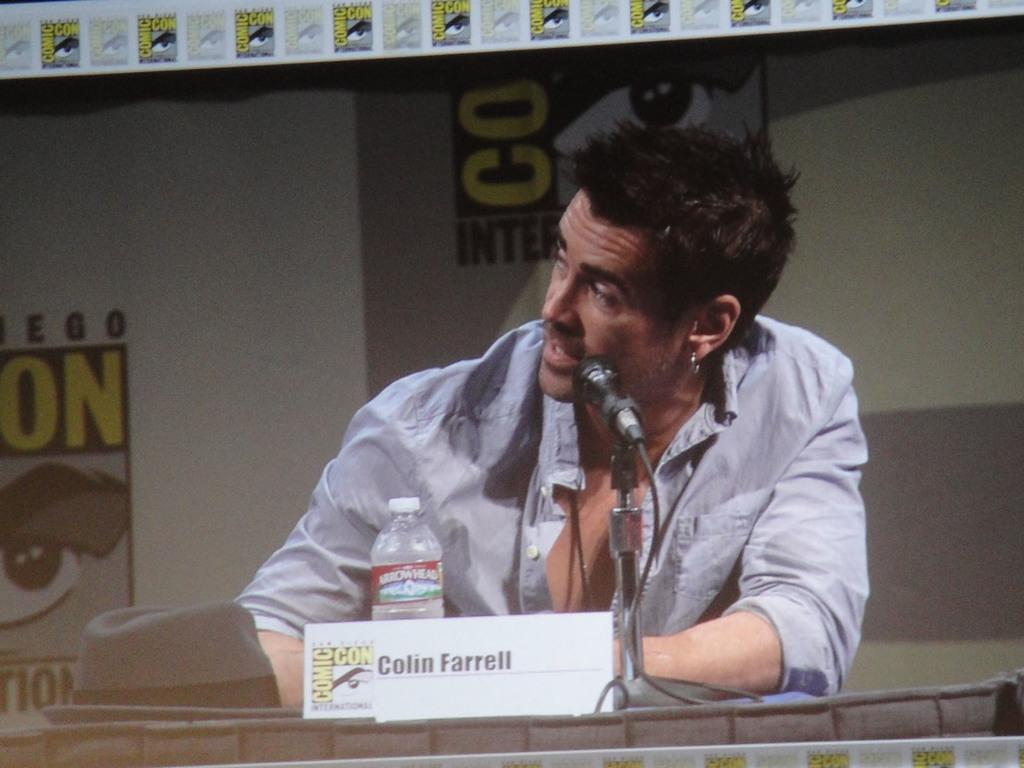Who or what is present in the image? There is a person in the image. What objects are on the podium in the image? There is a bottle, a hat, a board, and a mic on the podium. Can you describe the board on the podium? The board on the podium is likely for writing or displaying information. Is there anything else in the background of the image besides the board? No additional information is provided about the background of the image. What type of leather material is used for the mask in the image? There is no mask present in the image, so it is not possible to determine the type of leather material used. 